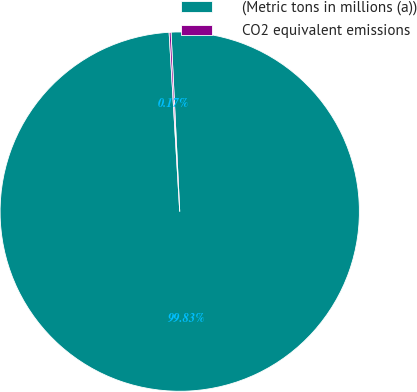Convert chart. <chart><loc_0><loc_0><loc_500><loc_500><pie_chart><fcel>(Metric tons in millions (a))<fcel>CO2 equivalent emissions<nl><fcel>99.83%<fcel>0.17%<nl></chart> 